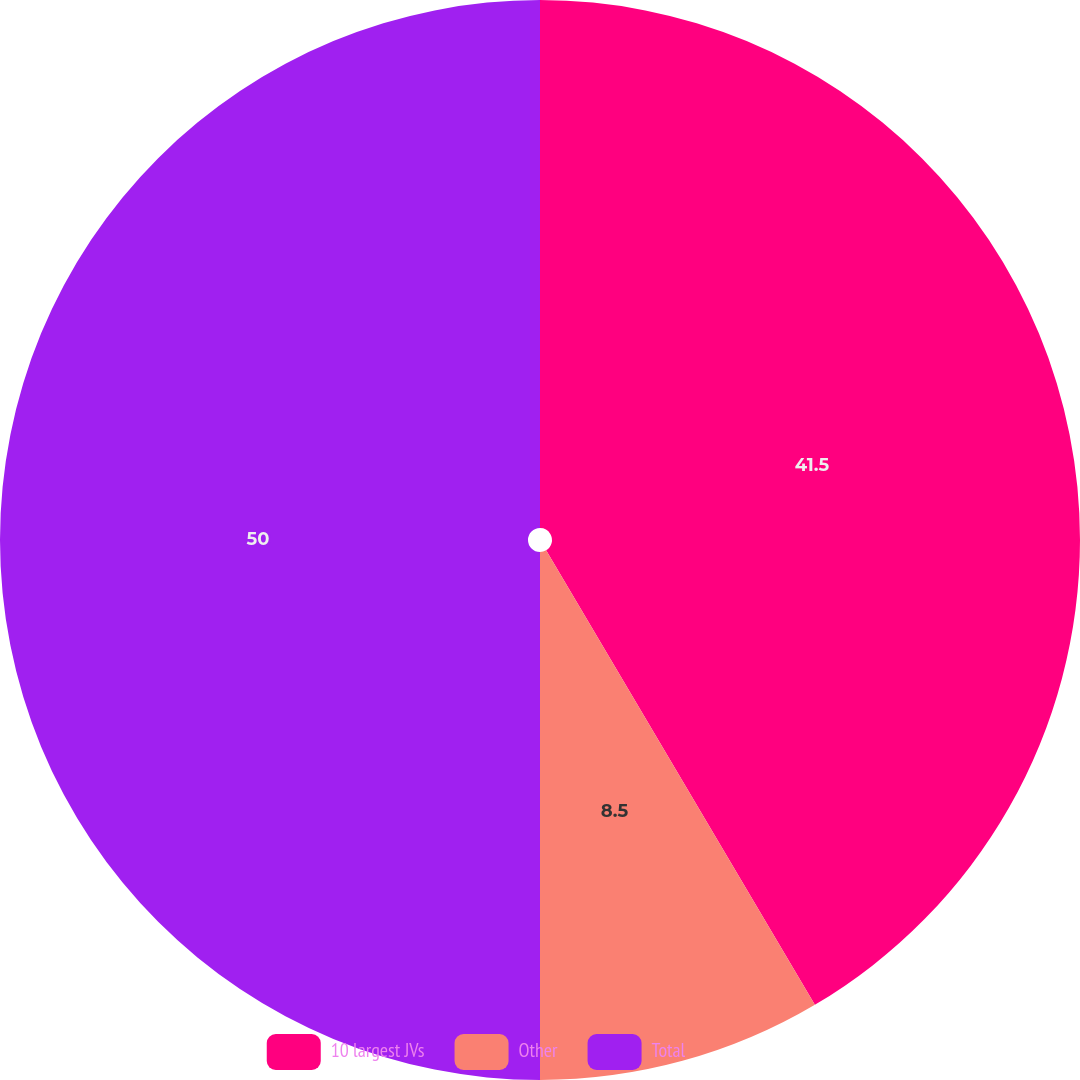Convert chart. <chart><loc_0><loc_0><loc_500><loc_500><pie_chart><fcel>10 largest JVs<fcel>Other<fcel>Total<nl><fcel>41.5%<fcel>8.5%<fcel>50.0%<nl></chart> 